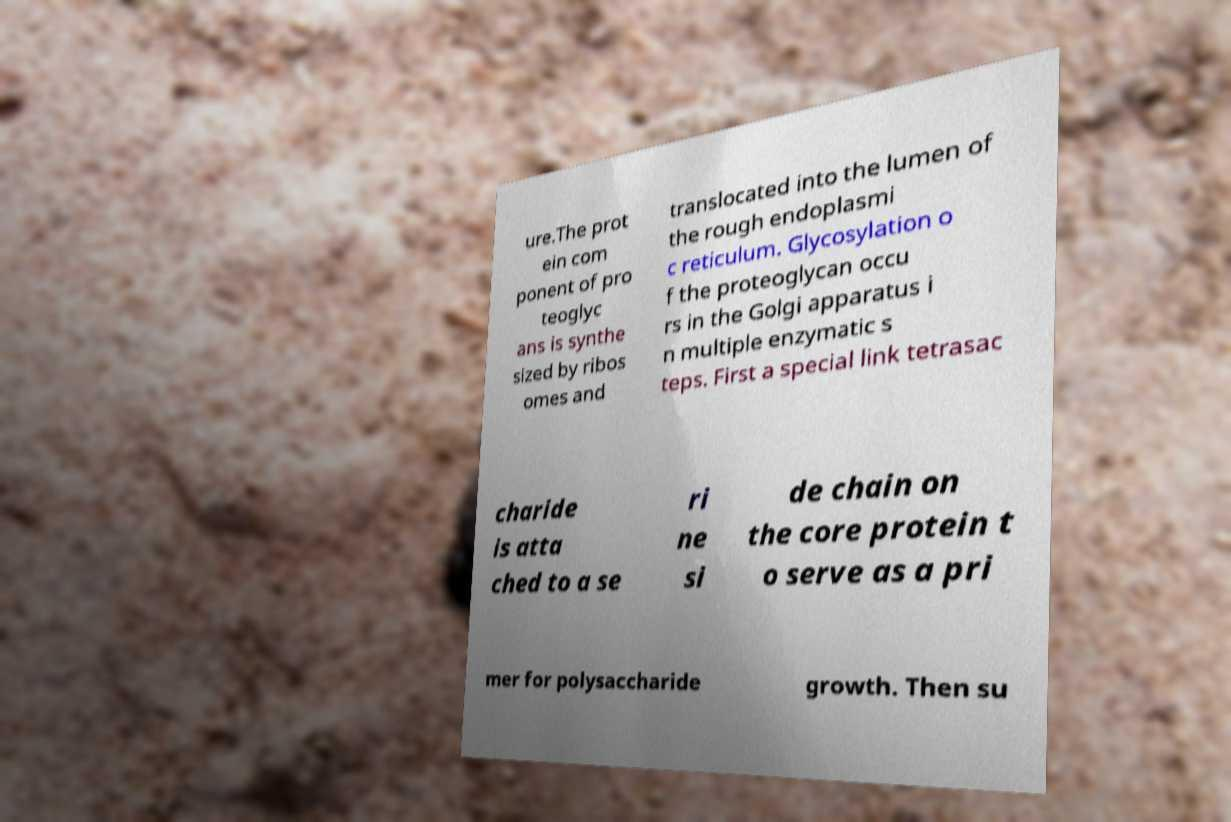I need the written content from this picture converted into text. Can you do that? ure.The prot ein com ponent of pro teoglyc ans is synthe sized by ribos omes and translocated into the lumen of the rough endoplasmi c reticulum. Glycosylation o f the proteoglycan occu rs in the Golgi apparatus i n multiple enzymatic s teps. First a special link tetrasac charide is atta ched to a se ri ne si de chain on the core protein t o serve as a pri mer for polysaccharide growth. Then su 